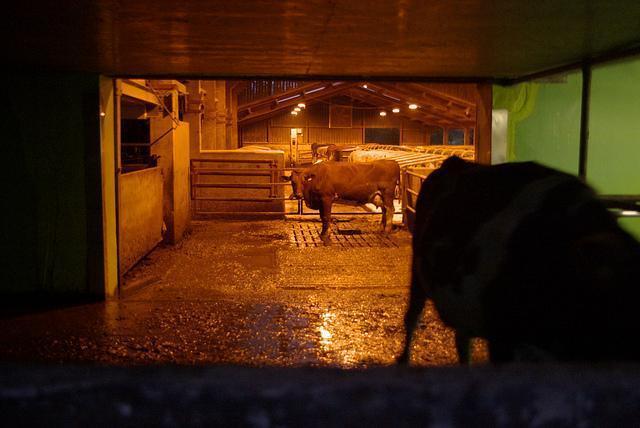How many cows?
Give a very brief answer. 2. How many cows can you see?
Give a very brief answer. 2. 